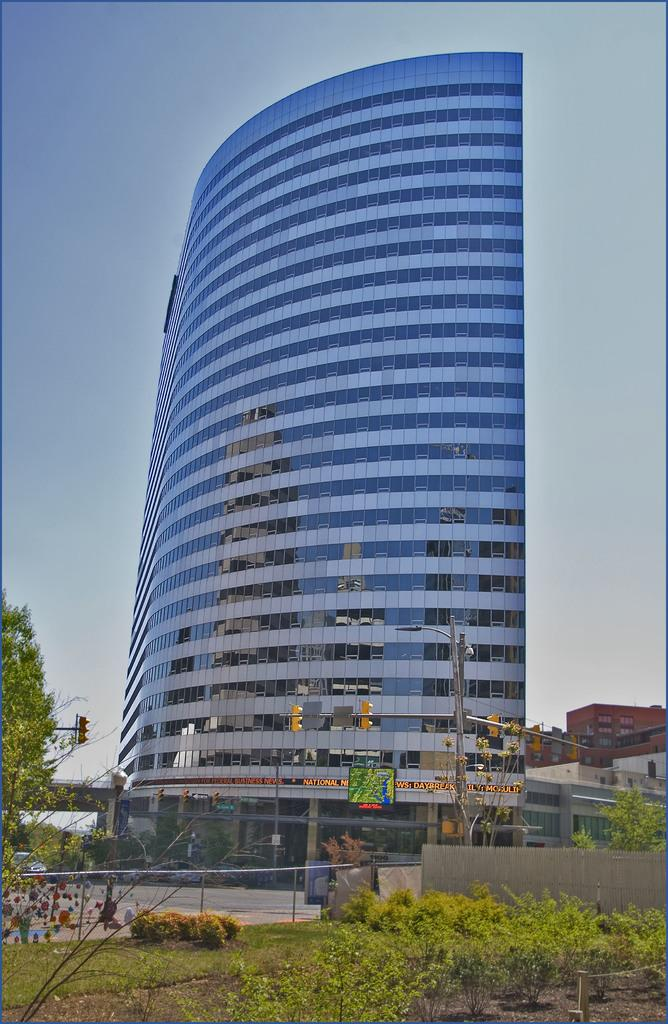What type of structures can be seen in the image? There are buildings in the image. What natural elements are present in the image? There are trees and plants in the image. What type of barrier can be seen in the image? There is a metal fence and a wooden fence in the image. What is on the road in the image? There is a vehicle on the road in the image. What traffic control device is visible in the image? The traffic lights are visible in the image. What else can be seen in the image? There is a street pole in the image. What is visible in the sky in the image? The sky is visible in the image. What type of calculator is being used by the tree in the image? There is no calculator present in the image, and trees do not use calculators. What caption is written on the wooden fence in the image? There is no caption written on the wooden fence in the image, as it is a physical barrier and not a textual element. What type of guitar is being played by the vehicle in the image? There is no guitar present in the image, and vehicles do not play musical instruments. 